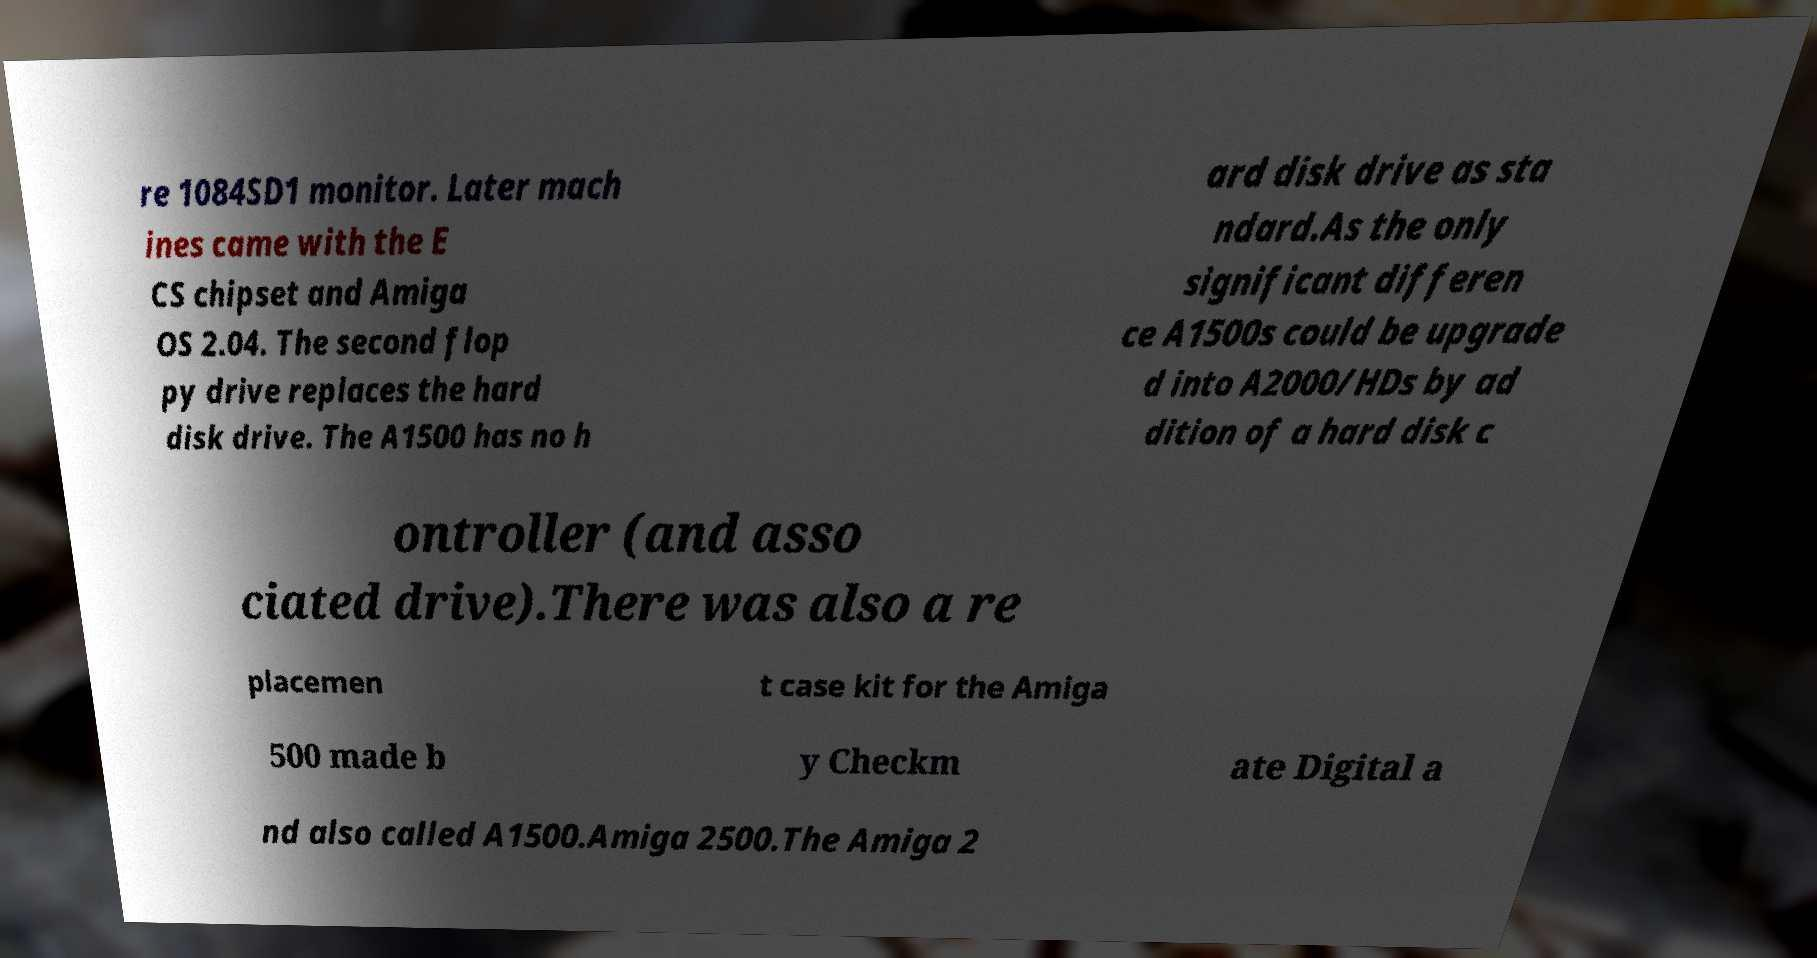Can you read and provide the text displayed in the image?This photo seems to have some interesting text. Can you extract and type it out for me? re 1084SD1 monitor. Later mach ines came with the E CS chipset and Amiga OS 2.04. The second flop py drive replaces the hard disk drive. The A1500 has no h ard disk drive as sta ndard.As the only significant differen ce A1500s could be upgrade d into A2000/HDs by ad dition of a hard disk c ontroller (and asso ciated drive).There was also a re placemen t case kit for the Amiga 500 made b y Checkm ate Digital a nd also called A1500.Amiga 2500.The Amiga 2 